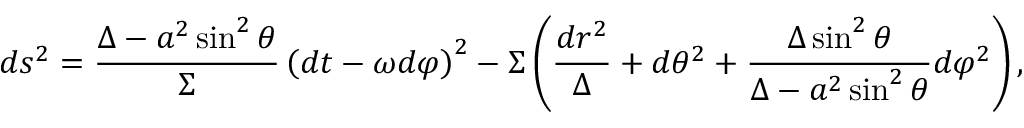<formula> <loc_0><loc_0><loc_500><loc_500>d s ^ { 2 } = \frac { \Delta - a ^ { 2 } \sin ^ { 2 } \theta } { \Sigma } \left ( d t - \omega d \varphi \right ) ^ { 2 } - \Sigma \left ( \frac { d r ^ { 2 } } { \Delta } + d \theta ^ { 2 } + \frac { \Delta \sin ^ { 2 } \theta } { \Delta - a ^ { 2 } \sin ^ { 2 } \theta } d \varphi ^ { 2 } \right ) ,</formula> 